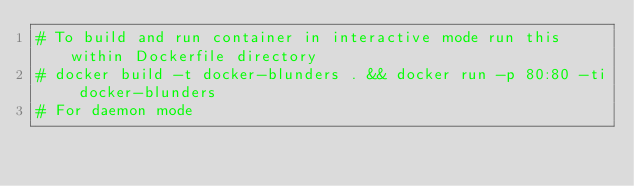Convert code to text. <code><loc_0><loc_0><loc_500><loc_500><_Dockerfile_># To build and run container in interactive mode run this within Dockerfile directory
# docker build -t docker-blunders . && docker run -p 80:80 -ti docker-blunders
# For daemon mode</code> 